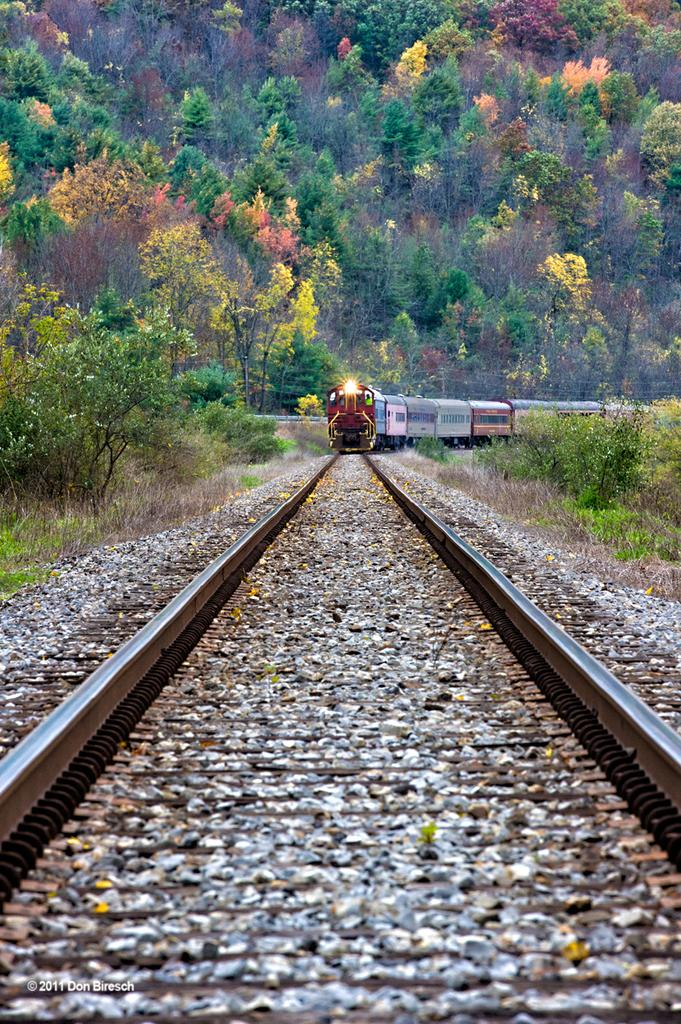What is the main subject of the image? There is a train in the image. Where is the train located? The train is on a railway track. What can be seen in the background of the image? There are trees in the background of the image. What type of finger can be seen holding the train in the image? There is no finger present in the image, and the train is not being held by any object or person. 